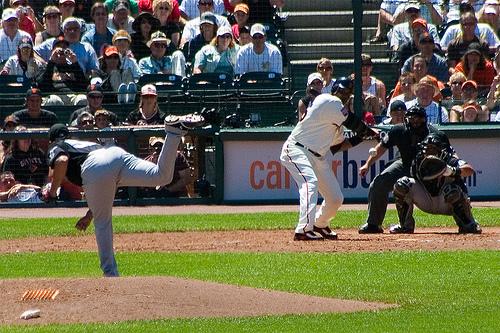Does the crowd appear packed?
Keep it brief. Yes. What sponsor is in the background?
Give a very brief answer. Careerbuilder. Has the pitcher lost his balance and preparing to fall?
Concise answer only. No. Is the batter left-handed?
Give a very brief answer. Yes. 